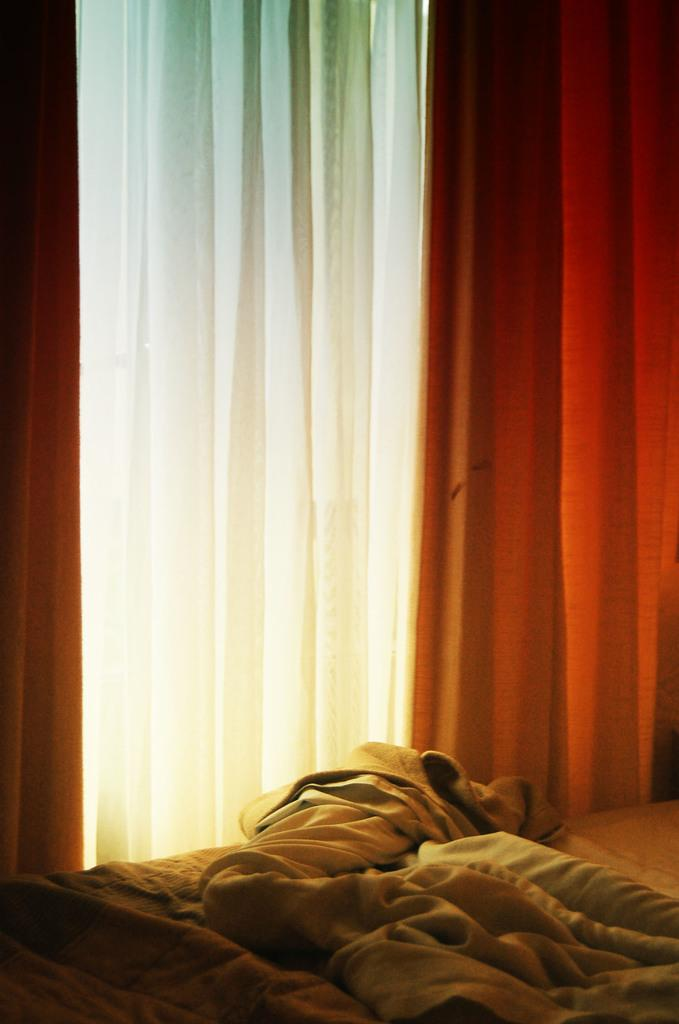What is covering the bed in the image? There are bed sheets on the bed. What type of window treatment can be seen in the image? There are curtains in the image. What type of tin can be seen on the bed in the image? There is no tin present on the bed in the image. How many trucks are visible in the image? There are no trucks visible in the image. 